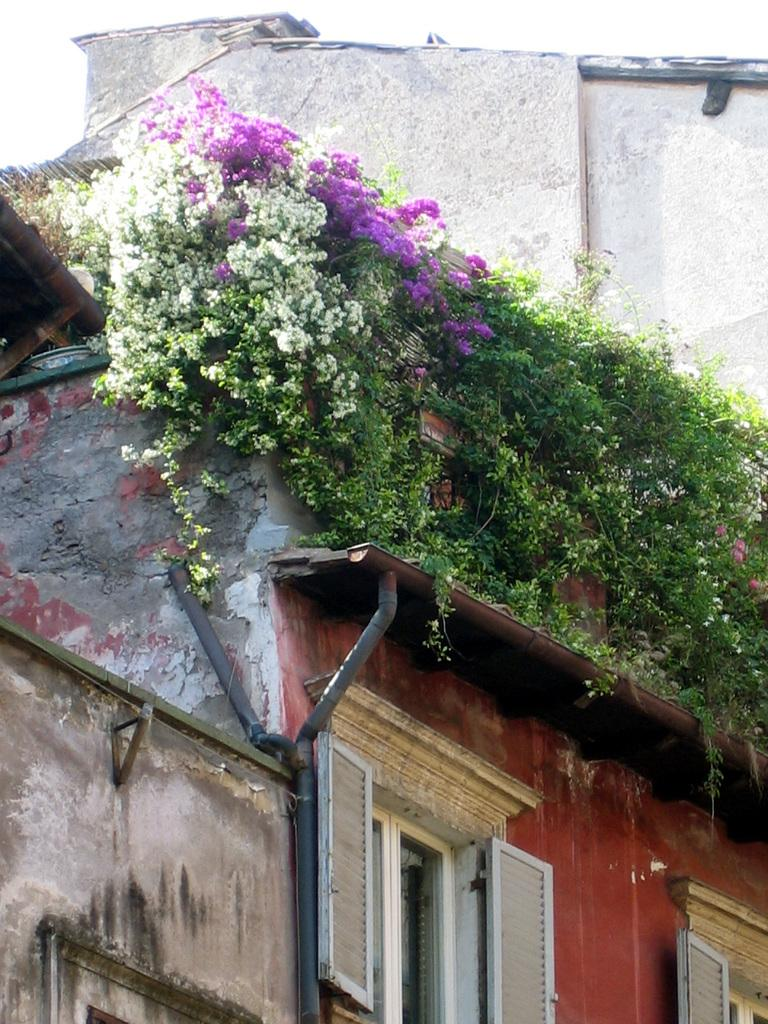What type of structure is present in the image? There is a building in the image. What feature can be seen on the building? The building has windows. What type of vegetation is present in the image? There are plants and flowers in the image. What other objects can be seen in the image? There is a pole and a wall in the image. What is visible in the background of the image? The sky is visible in the image. Can you tell me how many guns are hidden behind the wall in the image? There are no guns present in the image; it only features a building, plants, flowers, a pole, and a wall. What type of arithmetic problem can be solved using the information in the image? There is no arithmetic problem that can be solved using the information in the image, as it only provides visual details about a building, plants, flowers, a pole, and a wall. 